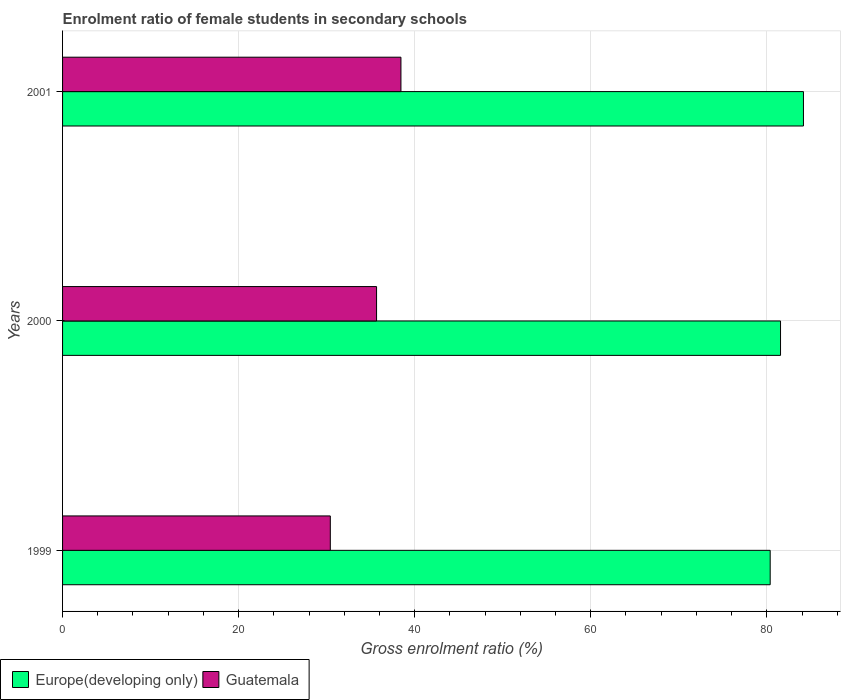How many different coloured bars are there?
Provide a short and direct response. 2. Are the number of bars on each tick of the Y-axis equal?
Your answer should be compact. Yes. How many bars are there on the 3rd tick from the top?
Your response must be concise. 2. What is the enrolment ratio of female students in secondary schools in Europe(developing only) in 2000?
Keep it short and to the point. 81.56. Across all years, what is the maximum enrolment ratio of female students in secondary schools in Europe(developing only)?
Provide a succinct answer. 84.16. Across all years, what is the minimum enrolment ratio of female students in secondary schools in Guatemala?
Provide a short and direct response. 30.42. In which year was the enrolment ratio of female students in secondary schools in Guatemala maximum?
Make the answer very short. 2001. In which year was the enrolment ratio of female students in secondary schools in Europe(developing only) minimum?
Your response must be concise. 1999. What is the total enrolment ratio of female students in secondary schools in Europe(developing only) in the graph?
Your answer should be very brief. 246.11. What is the difference between the enrolment ratio of female students in secondary schools in Europe(developing only) in 1999 and that in 2001?
Your answer should be compact. -3.78. What is the difference between the enrolment ratio of female students in secondary schools in Europe(developing only) in 2000 and the enrolment ratio of female students in secondary schools in Guatemala in 1999?
Your answer should be very brief. 51.15. What is the average enrolment ratio of female students in secondary schools in Guatemala per year?
Your answer should be compact. 34.84. In the year 2000, what is the difference between the enrolment ratio of female students in secondary schools in Europe(developing only) and enrolment ratio of female students in secondary schools in Guatemala?
Your response must be concise. 45.89. What is the ratio of the enrolment ratio of female students in secondary schools in Guatemala in 1999 to that in 2001?
Provide a succinct answer. 0.79. Is the enrolment ratio of female students in secondary schools in Guatemala in 1999 less than that in 2001?
Keep it short and to the point. Yes. What is the difference between the highest and the second highest enrolment ratio of female students in secondary schools in Europe(developing only)?
Ensure brevity in your answer.  2.6. What is the difference between the highest and the lowest enrolment ratio of female students in secondary schools in Guatemala?
Give a very brief answer. 8.02. What does the 2nd bar from the top in 2000 represents?
Offer a very short reply. Europe(developing only). What does the 2nd bar from the bottom in 2000 represents?
Offer a terse response. Guatemala. How many bars are there?
Offer a terse response. 6. What is the difference between two consecutive major ticks on the X-axis?
Your answer should be very brief. 20. How many legend labels are there?
Give a very brief answer. 2. What is the title of the graph?
Provide a short and direct response. Enrolment ratio of female students in secondary schools. What is the label or title of the Y-axis?
Offer a terse response. Years. What is the Gross enrolment ratio (%) in Europe(developing only) in 1999?
Make the answer very short. 80.39. What is the Gross enrolment ratio (%) in Guatemala in 1999?
Offer a terse response. 30.42. What is the Gross enrolment ratio (%) of Europe(developing only) in 2000?
Ensure brevity in your answer.  81.56. What is the Gross enrolment ratio (%) in Guatemala in 2000?
Ensure brevity in your answer.  35.67. What is the Gross enrolment ratio (%) in Europe(developing only) in 2001?
Offer a terse response. 84.16. What is the Gross enrolment ratio (%) of Guatemala in 2001?
Provide a short and direct response. 38.44. Across all years, what is the maximum Gross enrolment ratio (%) in Europe(developing only)?
Make the answer very short. 84.16. Across all years, what is the maximum Gross enrolment ratio (%) in Guatemala?
Offer a very short reply. 38.44. Across all years, what is the minimum Gross enrolment ratio (%) in Europe(developing only)?
Your answer should be compact. 80.39. Across all years, what is the minimum Gross enrolment ratio (%) of Guatemala?
Provide a short and direct response. 30.42. What is the total Gross enrolment ratio (%) of Europe(developing only) in the graph?
Provide a short and direct response. 246.11. What is the total Gross enrolment ratio (%) of Guatemala in the graph?
Your response must be concise. 104.52. What is the difference between the Gross enrolment ratio (%) in Europe(developing only) in 1999 and that in 2000?
Keep it short and to the point. -1.18. What is the difference between the Gross enrolment ratio (%) in Guatemala in 1999 and that in 2000?
Offer a terse response. -5.25. What is the difference between the Gross enrolment ratio (%) of Europe(developing only) in 1999 and that in 2001?
Keep it short and to the point. -3.78. What is the difference between the Gross enrolment ratio (%) in Guatemala in 1999 and that in 2001?
Your answer should be very brief. -8.02. What is the difference between the Gross enrolment ratio (%) in Europe(developing only) in 2000 and that in 2001?
Make the answer very short. -2.6. What is the difference between the Gross enrolment ratio (%) of Guatemala in 2000 and that in 2001?
Keep it short and to the point. -2.77. What is the difference between the Gross enrolment ratio (%) of Europe(developing only) in 1999 and the Gross enrolment ratio (%) of Guatemala in 2000?
Give a very brief answer. 44.72. What is the difference between the Gross enrolment ratio (%) of Europe(developing only) in 1999 and the Gross enrolment ratio (%) of Guatemala in 2001?
Your response must be concise. 41.95. What is the difference between the Gross enrolment ratio (%) of Europe(developing only) in 2000 and the Gross enrolment ratio (%) of Guatemala in 2001?
Make the answer very short. 43.12. What is the average Gross enrolment ratio (%) of Europe(developing only) per year?
Offer a very short reply. 82.04. What is the average Gross enrolment ratio (%) in Guatemala per year?
Ensure brevity in your answer.  34.84. In the year 1999, what is the difference between the Gross enrolment ratio (%) of Europe(developing only) and Gross enrolment ratio (%) of Guatemala?
Your answer should be very brief. 49.97. In the year 2000, what is the difference between the Gross enrolment ratio (%) of Europe(developing only) and Gross enrolment ratio (%) of Guatemala?
Offer a very short reply. 45.89. In the year 2001, what is the difference between the Gross enrolment ratio (%) in Europe(developing only) and Gross enrolment ratio (%) in Guatemala?
Ensure brevity in your answer.  45.73. What is the ratio of the Gross enrolment ratio (%) of Europe(developing only) in 1999 to that in 2000?
Your answer should be compact. 0.99. What is the ratio of the Gross enrolment ratio (%) of Guatemala in 1999 to that in 2000?
Provide a succinct answer. 0.85. What is the ratio of the Gross enrolment ratio (%) in Europe(developing only) in 1999 to that in 2001?
Offer a terse response. 0.96. What is the ratio of the Gross enrolment ratio (%) in Guatemala in 1999 to that in 2001?
Keep it short and to the point. 0.79. What is the ratio of the Gross enrolment ratio (%) of Europe(developing only) in 2000 to that in 2001?
Provide a succinct answer. 0.97. What is the ratio of the Gross enrolment ratio (%) of Guatemala in 2000 to that in 2001?
Your response must be concise. 0.93. What is the difference between the highest and the second highest Gross enrolment ratio (%) of Europe(developing only)?
Keep it short and to the point. 2.6. What is the difference between the highest and the second highest Gross enrolment ratio (%) in Guatemala?
Offer a very short reply. 2.77. What is the difference between the highest and the lowest Gross enrolment ratio (%) in Europe(developing only)?
Ensure brevity in your answer.  3.78. What is the difference between the highest and the lowest Gross enrolment ratio (%) of Guatemala?
Provide a short and direct response. 8.02. 